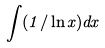Convert formula to latex. <formula><loc_0><loc_0><loc_500><loc_500>\int ( 1 / \ln x ) d x</formula> 